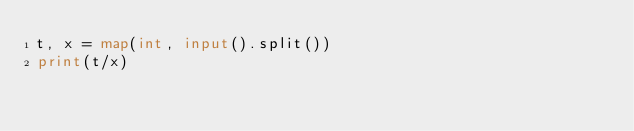<code> <loc_0><loc_0><loc_500><loc_500><_Python_>t, x = map(int, input().split())
print(t/x)</code> 